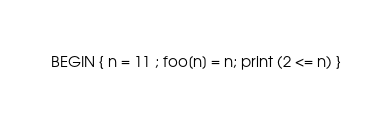Convert code to text. <code><loc_0><loc_0><loc_500><loc_500><_Awk_>BEGIN { n = 11 ; foo[n] = n; print (2 <= n) }
</code> 